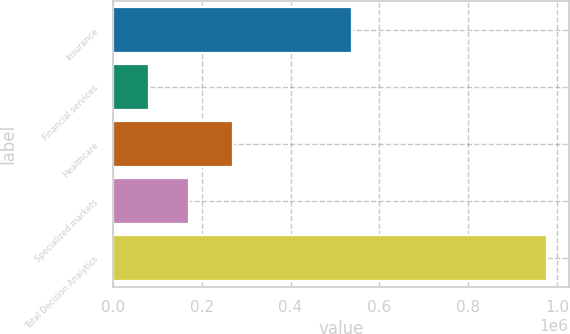Convert chart. <chart><loc_0><loc_0><loc_500><loc_500><bar_chart><fcel>Insurance<fcel>Financial services<fcel>Healthcare<fcel>Specialized markets<fcel>Total Decision Analytics<nl><fcel>539150<fcel>81113<fcel>271538<fcel>170744<fcel>977427<nl></chart> 